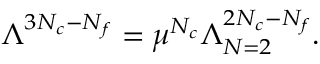Convert formula to latex. <formula><loc_0><loc_0><loc_500><loc_500>\Lambda ^ { 3 N _ { c } - N _ { f } } = \mu ^ { N _ { c } } \Lambda _ { N = 2 } ^ { 2 N _ { c } - N _ { f } } .</formula> 